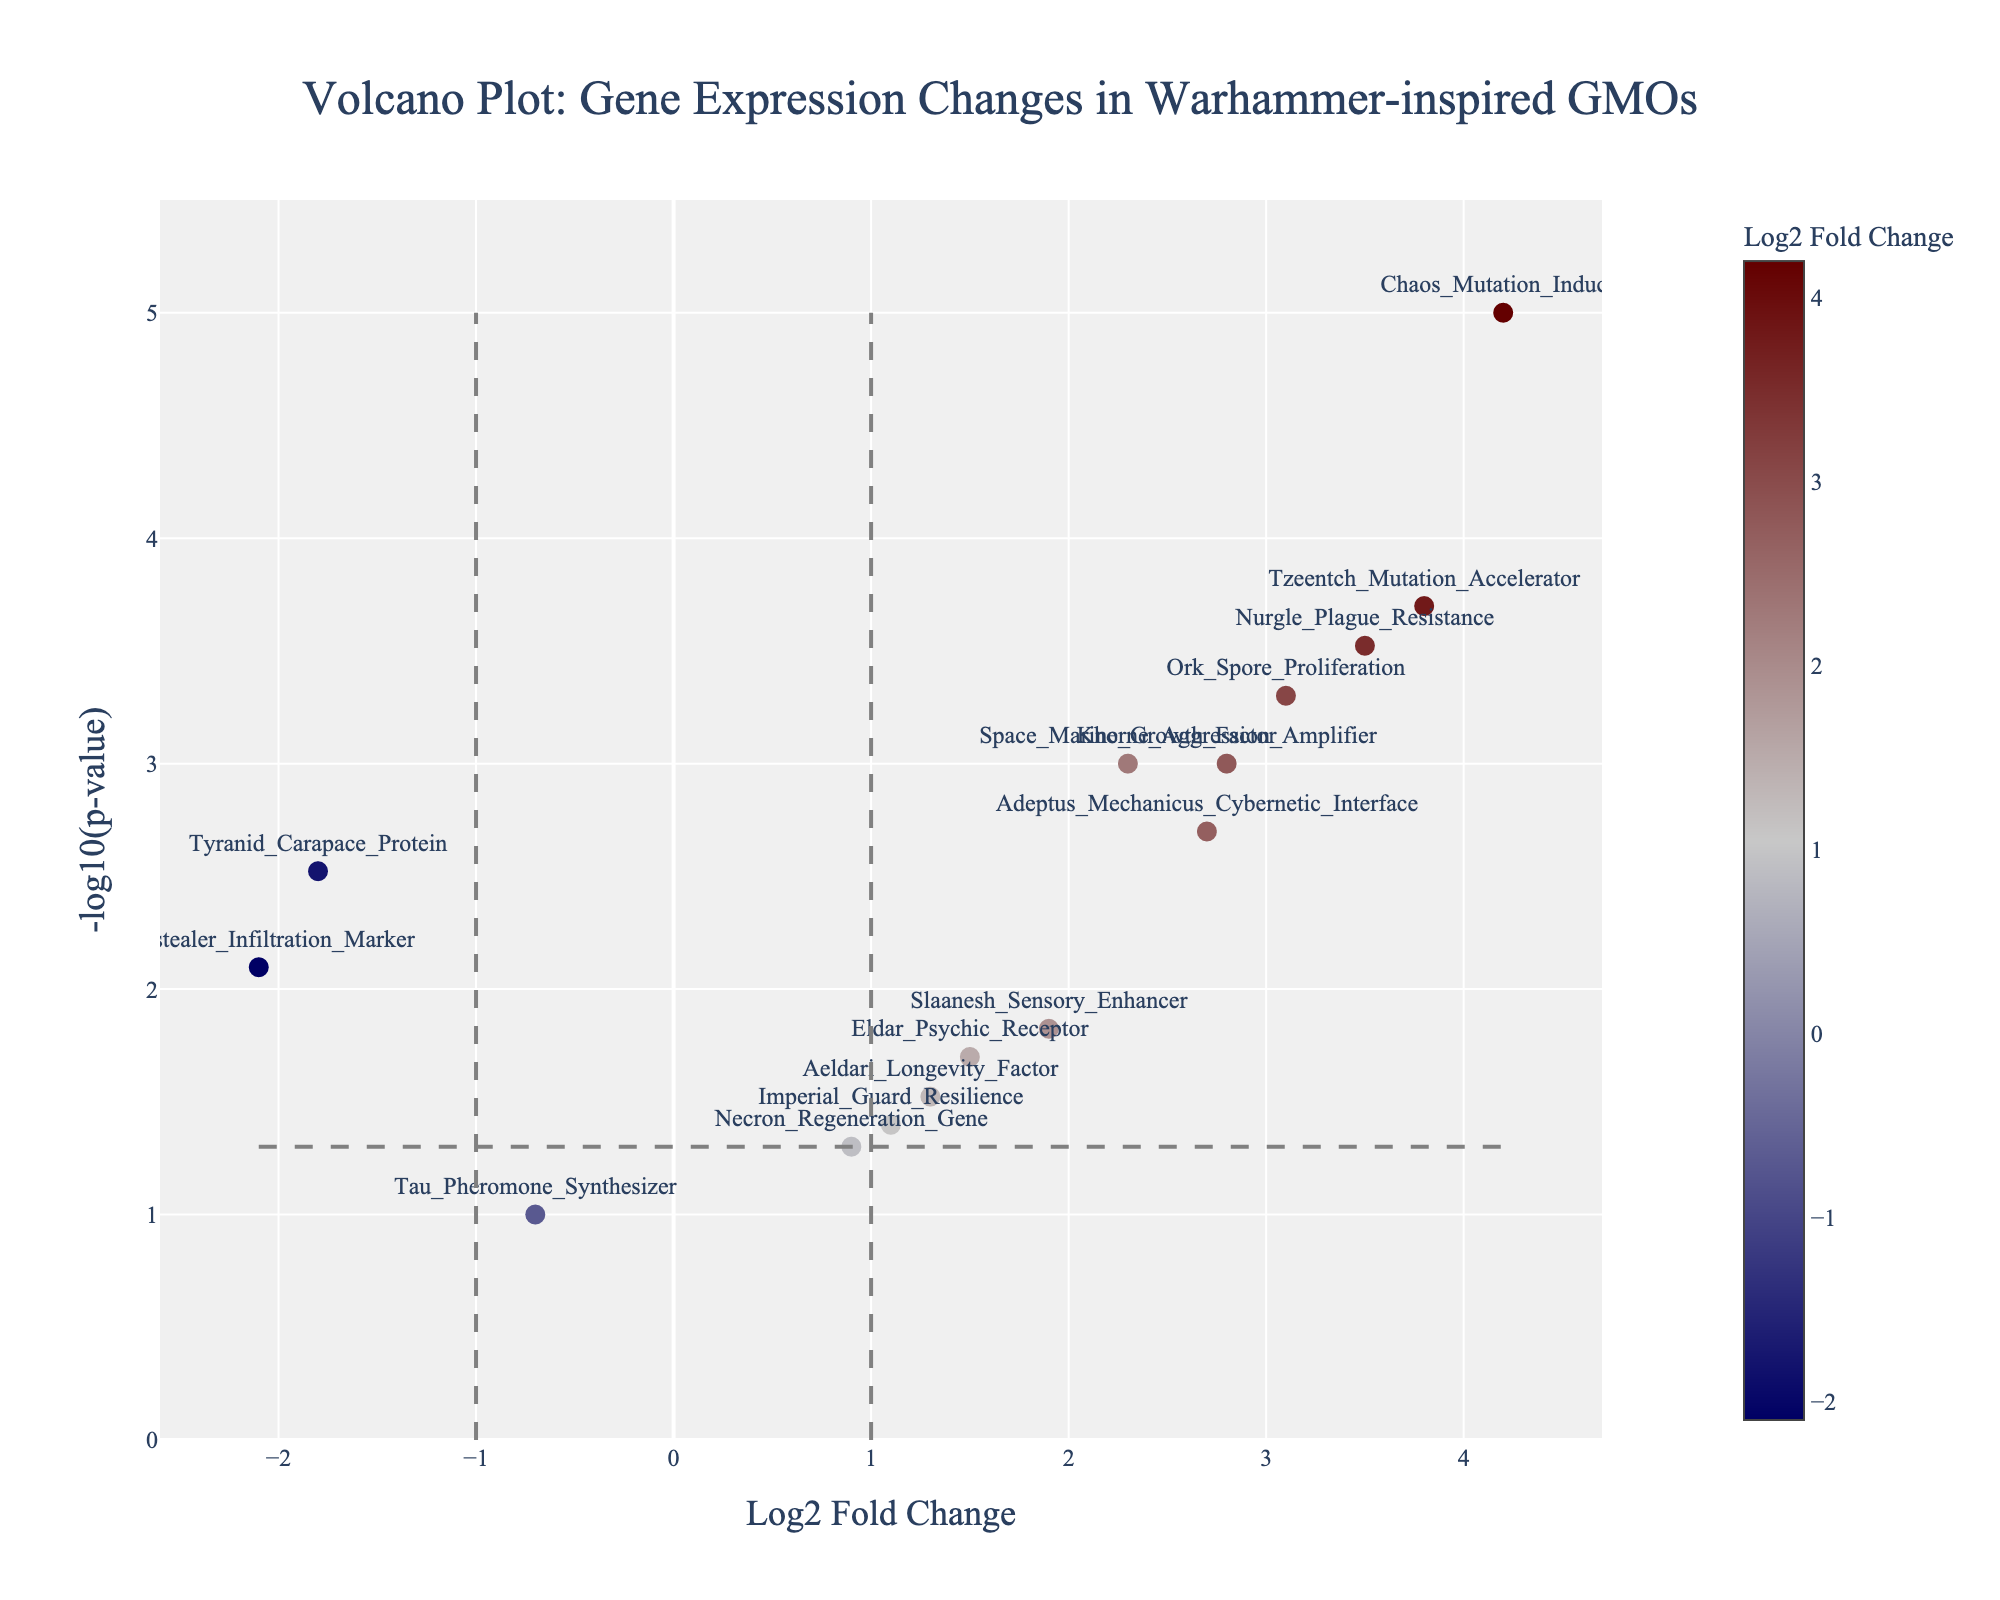How many genes show a significant change with a p-value less than 0.05? To determine the number of significant genes, count all the data points that have a -log10(p-value) greater than around 1.3 (since -log10(0.05) is approximately 1.3).
Answer: 12 Which gene has the highest log2 fold change and how significant is it? Identify the gene with the highest value on the x-axis and look up at its corresponding y-value for significance. The highest value for log2 fold change is for "Chaos_Mutation_Inducer", and its -log10(p-value) is the highest.
Answer: Chaos_Mutation_Inducer, very significant What is the log2 fold change and significance level of the gene 'Adeptus_Mechanicus_Cybernetic_Interface'? Locate "Adeptus_Mechanicus_Cybernetic_Interface", then check its position on the x-axis for log2 fold change and y-axis for -log10(p-value). The log2 fold change is 2.7, and the -log10(p-value) is approximately 2.7.
Answer: 2.7, highly significant Compare the log2 fold changes of 'Ork_Spore_Proliferation' and 'Genestealer_Infiltration_Marker'. Which one shows a greater change? Find both genes on the x-axis and compare their log2 fold change values. "Ork_Spore_Proliferation" has a log2 fold change of 3.1, and "Genestealer_Infiltration_Marker" has -2.1.
Answer: Ork_Spore_Proliferation Which gene has the lowest log2 fold change among those with a significant p-value (less than 0.05)? Look at all the significant data points and find the point that is furthest to the left on the x-axis. "Genestealer_Infiltration_Marker" has the lowest log2 fold change.
Answer: Genestealer_Infiltration_Marker What are the p-value and log2 fold change for 'Nurgle_Plague_Resistance'? Locate "Nurgle_Plague_Resistance" on the plot; check its position on the x-axis for the log2 fold change and convert -log10(p-value) back to p-value. The log2 fold change is 3.5, and the p-value is 0.0003.
Answer: p-value: 0.0003, log2 fold change: 3.5 Which two genes have the closest log2 fold change values and are both significant? Identify the significant data points first and then compare their log2 fold changes to find the closest pair. "Khorne_Aggression_Amplifier" and "Adeptus_Mechanicus_Cybernetic_Interface" have very close log2 fold change values (2.8 and 2.7).
Answer: Khorne_Aggression_Amplifier and Adeptus_Mechanicus_Cybernetic_Interface Is 'Tau_Pheromone_Synthesizer' considered significant in this analysis? Look at the position of "Tau_Pheromone_Synthesizer" on the y-axis and determine if its -log10(p-value) exceeds the threshold line of around 1.3. It does not exceed the threshold line.
Answer: No Which gene has the highest -log10(p-value) among those with a log2 fold change greater than 2? Look at data points where the x-value is greater than 2 and find the one with the highest y-value. "Chaos_Mutation_Inducer" has both a log2 fold change greater than 2 and the highest -log10(p-value).
Answer: Chaos_Mutation_Inducer 